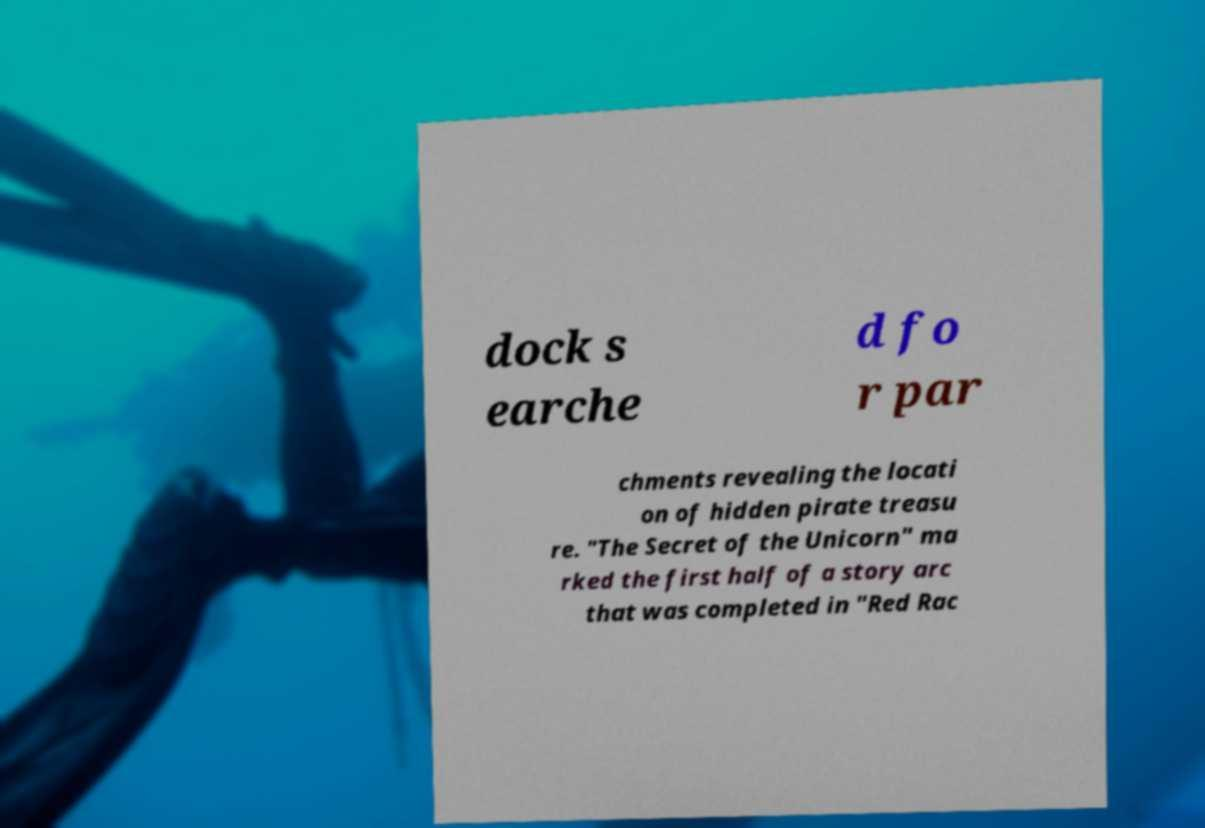I need the written content from this picture converted into text. Can you do that? dock s earche d fo r par chments revealing the locati on of hidden pirate treasu re. "The Secret of the Unicorn" ma rked the first half of a story arc that was completed in "Red Rac 